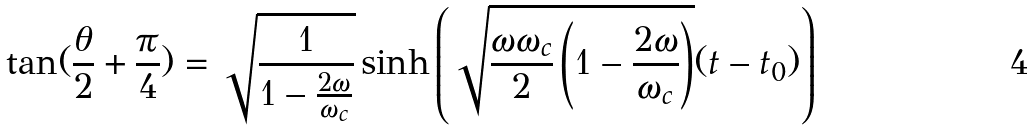Convert formula to latex. <formula><loc_0><loc_0><loc_500><loc_500>\tan ( { \frac { \theta } { 2 } + \frac { \pi } { 4 } } ) = \sqrt { \frac { 1 } { 1 - \frac { 2 \omega } { \omega _ { c } } } } \sinh \left ( \sqrt { \frac { \omega \omega _ { c } } { 2 } \left ( 1 - \frac { 2 \omega } { \omega _ { c } } \right ) } ( t - t _ { 0 } ) \right )</formula> 